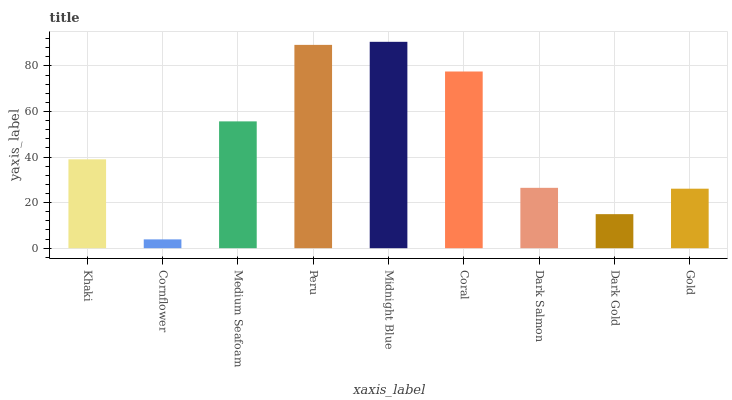Is Medium Seafoam the minimum?
Answer yes or no. No. Is Medium Seafoam the maximum?
Answer yes or no. No. Is Medium Seafoam greater than Cornflower?
Answer yes or no. Yes. Is Cornflower less than Medium Seafoam?
Answer yes or no. Yes. Is Cornflower greater than Medium Seafoam?
Answer yes or no. No. Is Medium Seafoam less than Cornflower?
Answer yes or no. No. Is Khaki the high median?
Answer yes or no. Yes. Is Khaki the low median?
Answer yes or no. Yes. Is Dark Gold the high median?
Answer yes or no. No. Is Coral the low median?
Answer yes or no. No. 